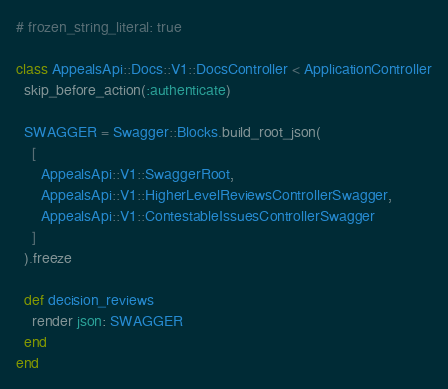Convert code to text. <code><loc_0><loc_0><loc_500><loc_500><_Ruby_># frozen_string_literal: true

class AppealsApi::Docs::V1::DocsController < ApplicationController
  skip_before_action(:authenticate)

  SWAGGER = Swagger::Blocks.build_root_json(
    [
      AppealsApi::V1::SwaggerRoot,
      AppealsApi::V1::HigherLevelReviewsControllerSwagger,
      AppealsApi::V1::ContestableIssuesControllerSwagger
    ]
  ).freeze

  def decision_reviews
    render json: SWAGGER
  end
end
</code> 